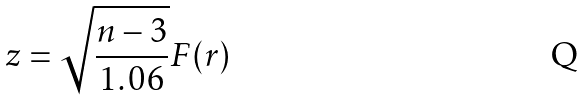<formula> <loc_0><loc_0><loc_500><loc_500>z = \sqrt { \frac { n - 3 } { 1 . 0 6 } } F ( r )</formula> 